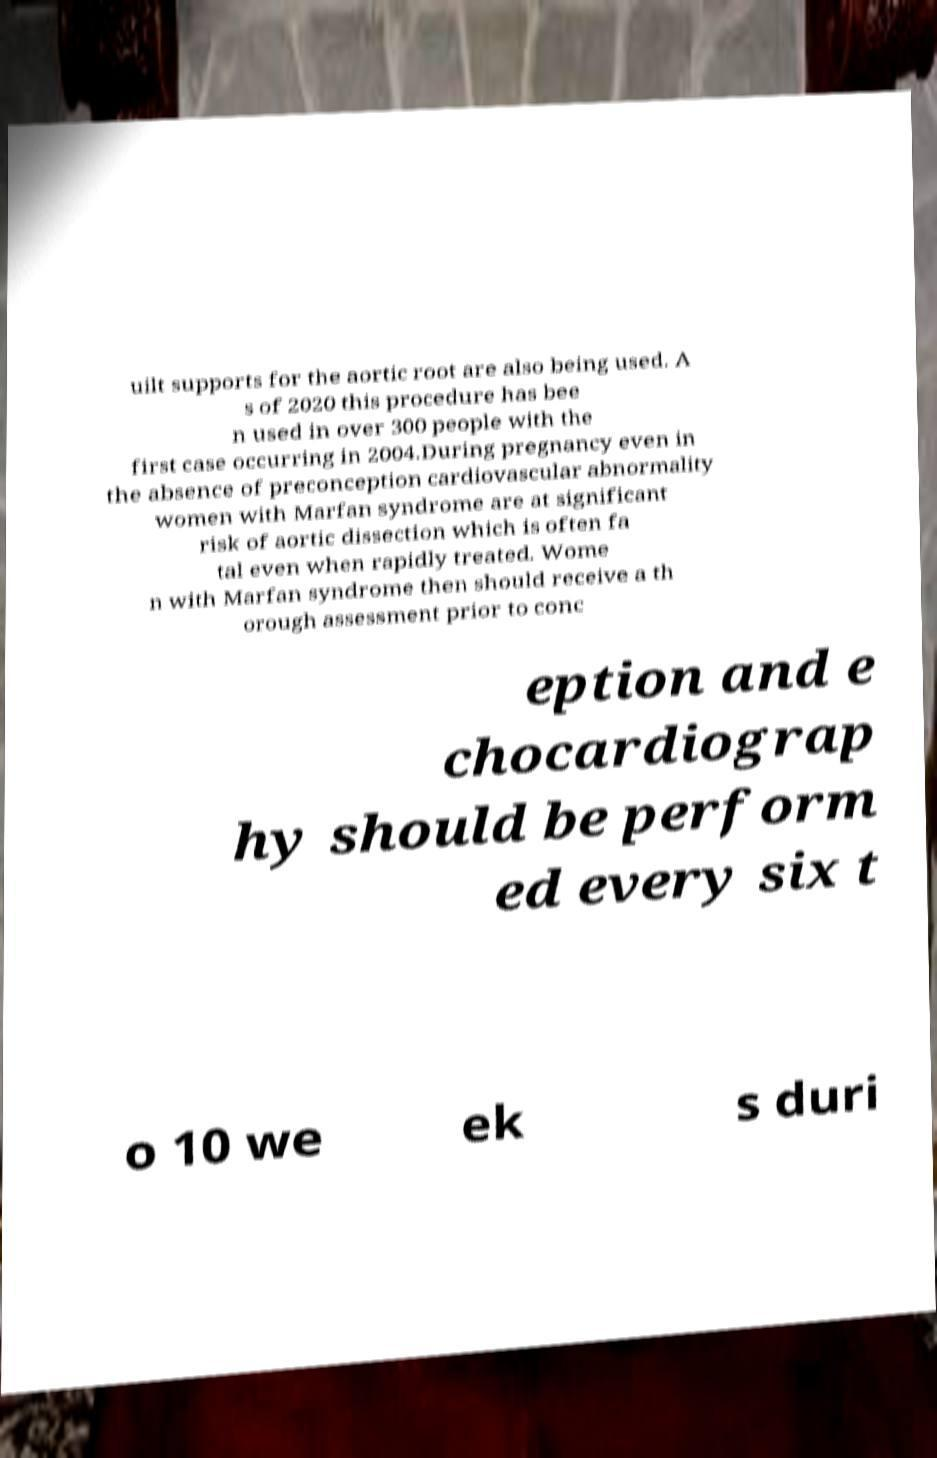Please read and relay the text visible in this image. What does it say? uilt supports for the aortic root are also being used. A s of 2020 this procedure has bee n used in over 300 people with the first case occurring in 2004.During pregnancy even in the absence of preconception cardiovascular abnormality women with Marfan syndrome are at significant risk of aortic dissection which is often fa tal even when rapidly treated. Wome n with Marfan syndrome then should receive a th orough assessment prior to conc eption and e chocardiograp hy should be perform ed every six t o 10 we ek s duri 